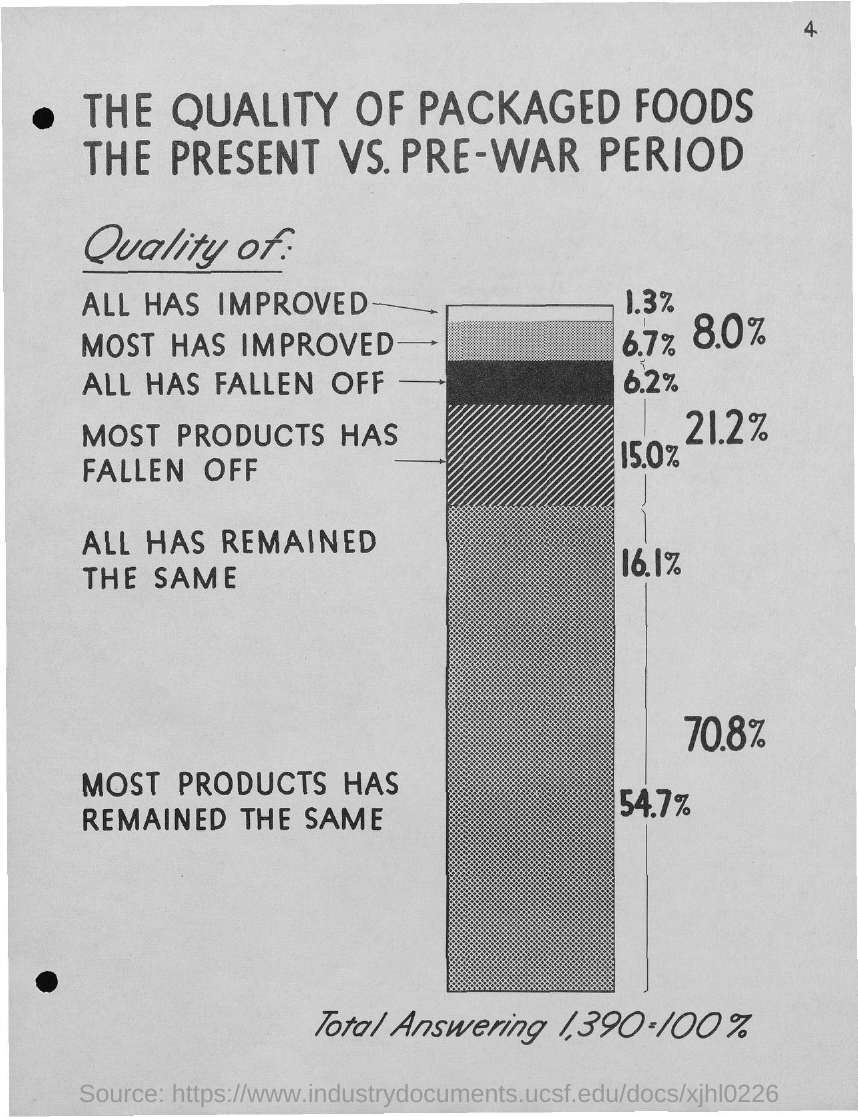List a handful of essential elements in this visual. The first title in the document is 'The quality of packaged foods.' The page number is 4. 